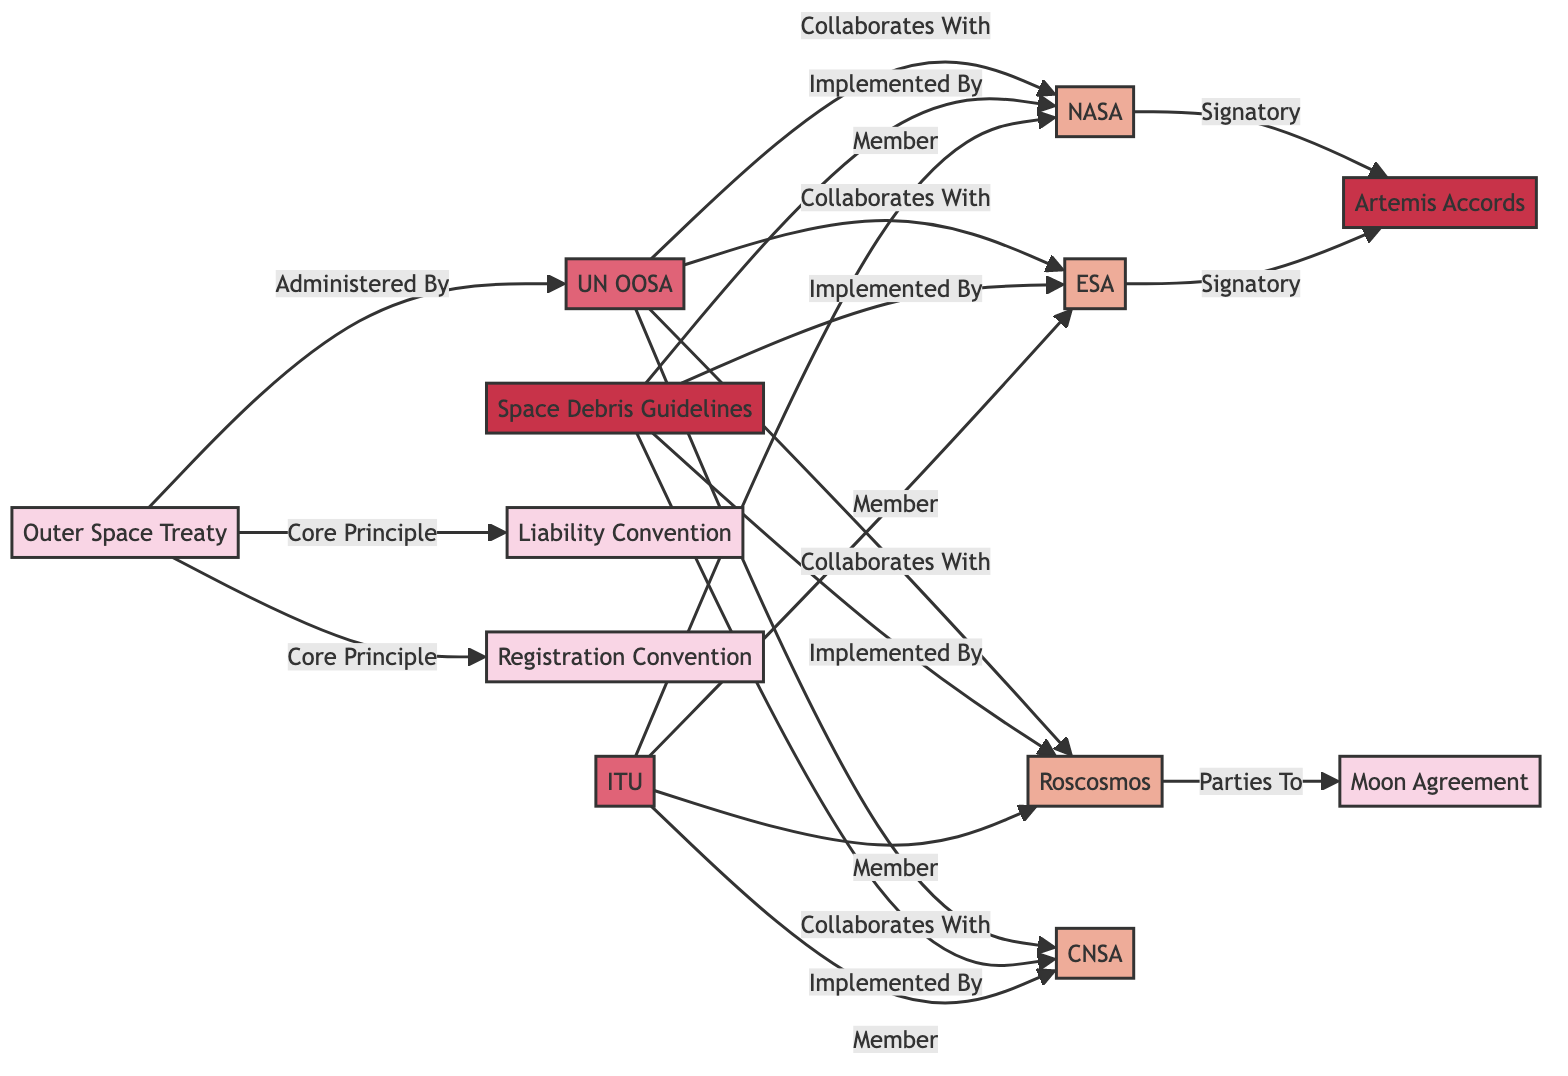What is the core principle of the Outer Space Treaty? The core principles of the Outer Space Treaty are represented by the interconnected nodes. In this case, both the Liability Convention and Registration Convention are identified as core principles. Therefore, the core principles associated with the Outer Space Treaty include these two treaties.
Answer: Liability Convention, Registration Convention How many agencies collaborate with the UN OOSA? The diagram shows that the UN OOSA collaborates with four agencies: NASA, ESA, Roscosmos, and CNSA. By counting the edges that connect the UN OOSA to these agencies, it's clear there are four distinct connections.
Answer: 4 Which agreement is implemented by the space agencies? According to the diagram, the Space Debris Guidelines is the agreement that is implemented by NASA, ESA, Roscosmos, and CNSA. This is shown by the direct connection labeled "Implemented By" leading to those agencies.
Answer: Space Debris Guidelines Who administers the Outer Space Treaty? The diagram specifies that the Outer Space Treaty is administered by the UN OOSA. The connection labeled "Administered By" directly links the Outer Space Treaty to the UN OOSA, indicating its role.
Answer: UN OOSA What is the relationship between the Artemis Accords and the space agencies? The diagram shows that both NASA and ESA are signatories of the Artemis Accords. This relationship is derived from the connection labeled "Signatory," which directly connects these agencies to the Artemis Accords.
Answer: Signatory How many treaties are represented in this diagram? By examining all the nodes that are classified under the "treaty" category, we can identify six distinct treaties in the diagram: Outer Space Treaty, Moon Agreement, Liability Convention, and Registration Convention. Thus, the total count of treaties is determined by simply counting those nodes.
Answer: 4 Which organization is a member of the International Telecommunication Union (ITU)? From the diagram, it is clear that NASA, ESA, Roscosmos, and CNSA are the agencies classified as members of the International Telecommunication Union (ITU). This indicates that all four of these agencies share membership in this organization.
Answer: NASA, ESA, Roscosmos, CNSA Name one party to the Moon Agreement. The diagram shows that Roscosmos is represented as a party to the Moon Agreement. This is evident from the connection labeled "Parties To" linking Roscosmos to the Moon Agreement.
Answer: Roscosmos 